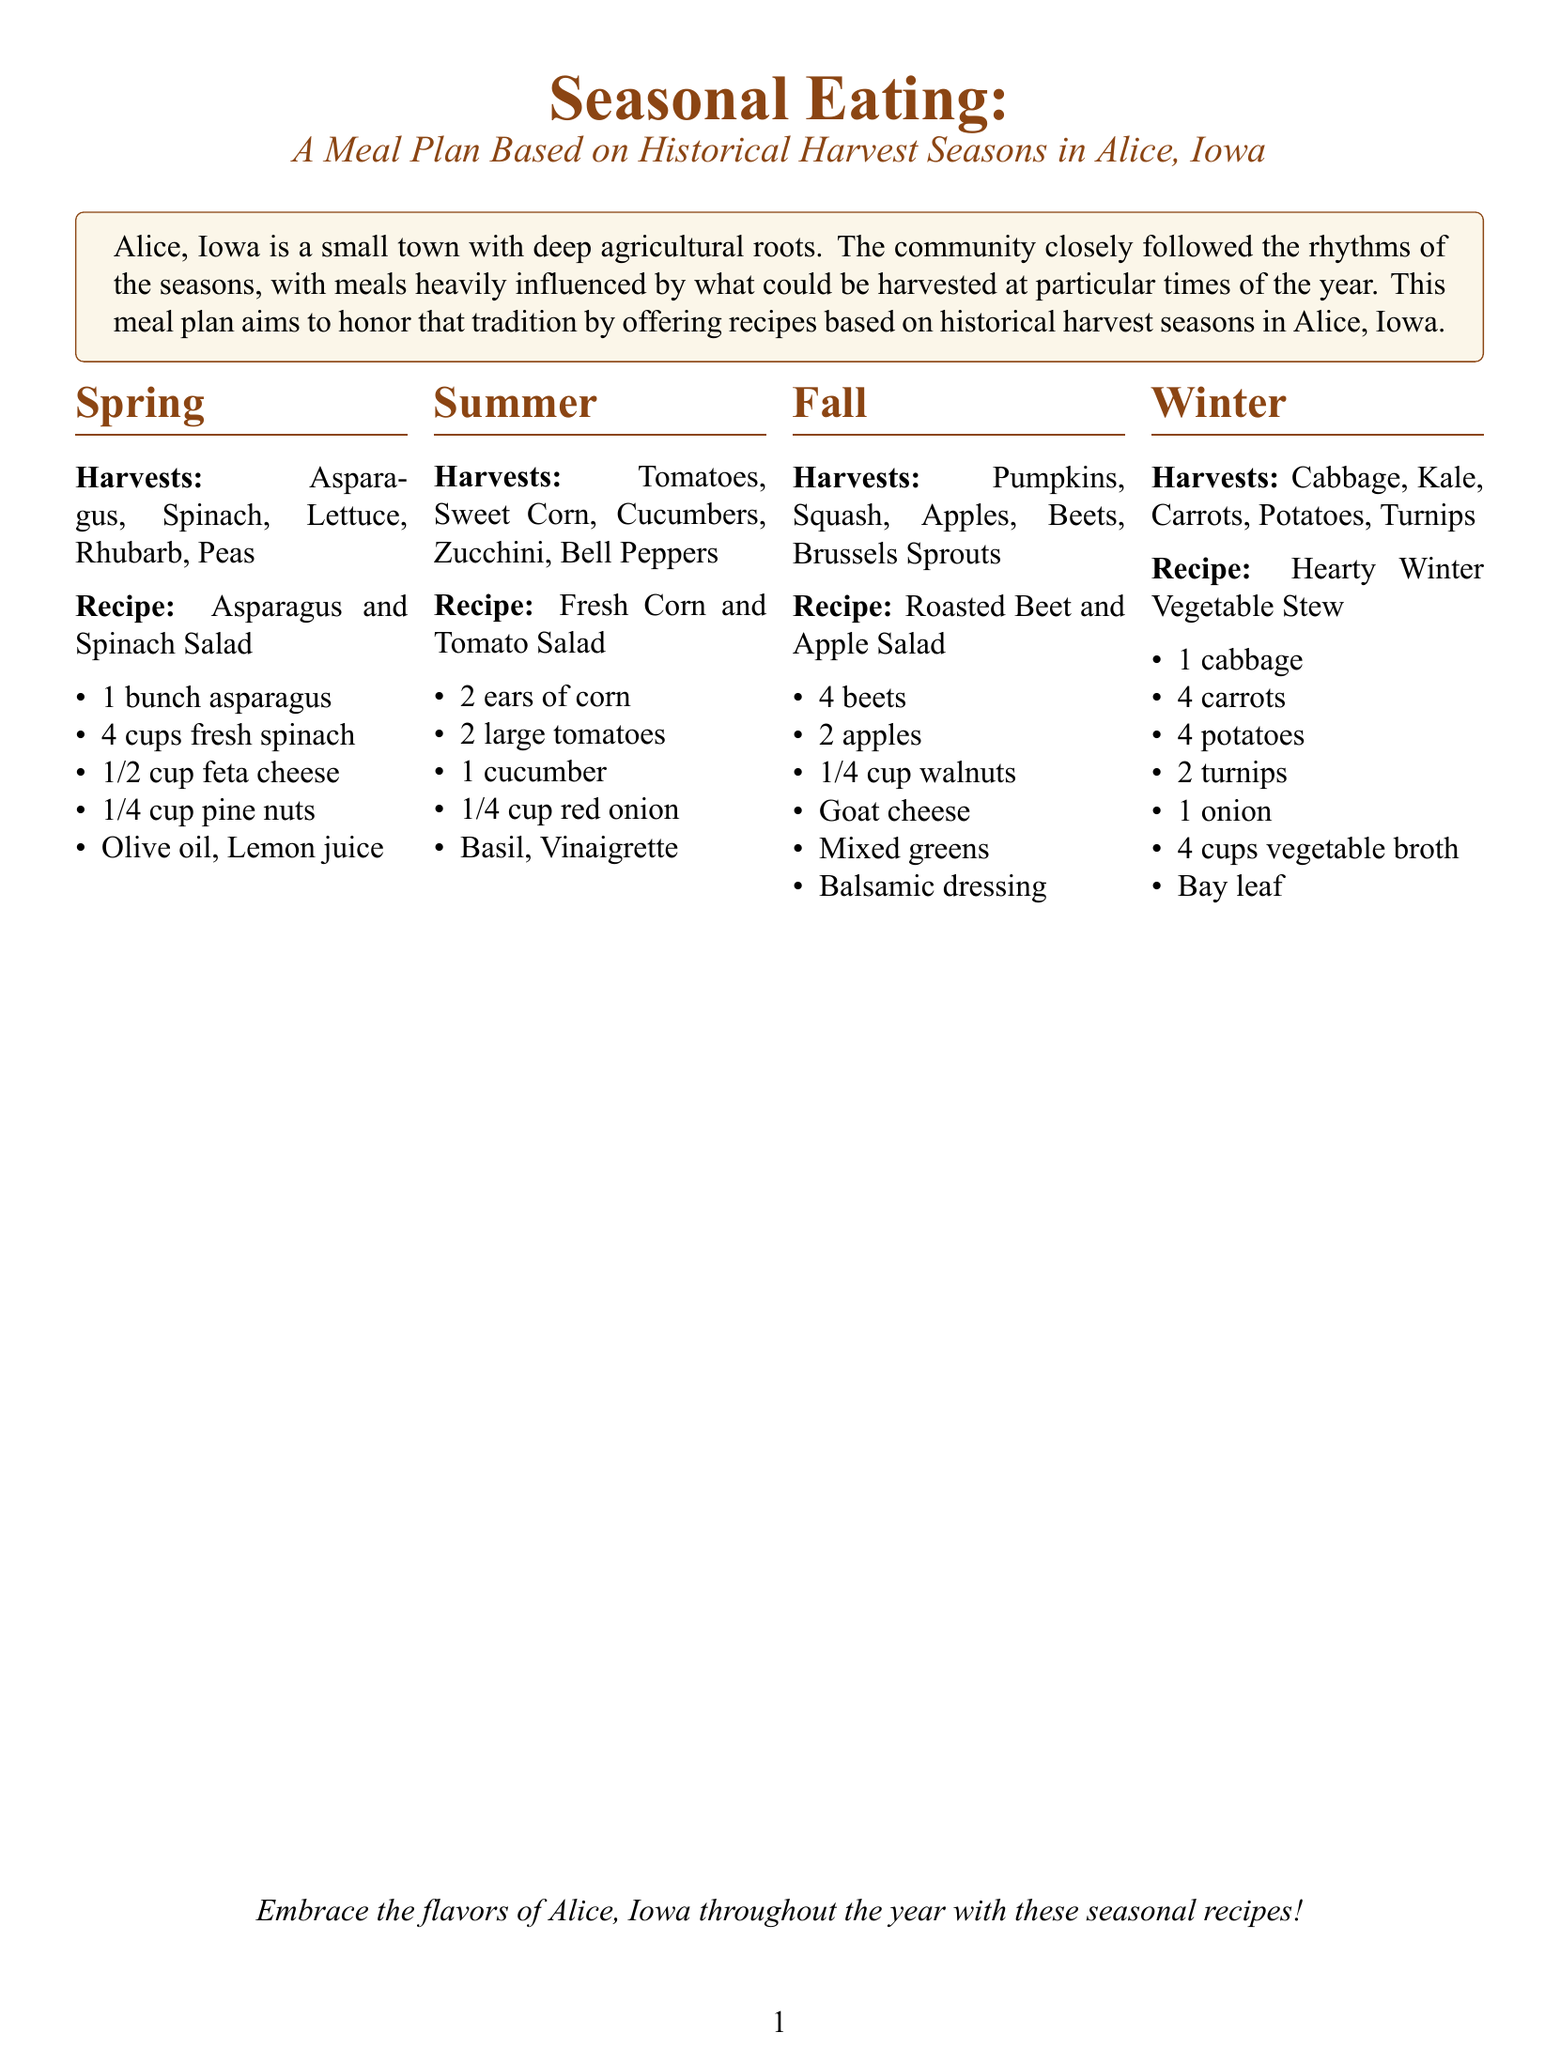What are the spring harvests listed? The spring harvests include specific vegetables and plants that can be grown and harvested in that season. The document lists Asparagus, Spinach, Lettuce, Rhubarb, and Peas.
Answer: Asparagus, Spinach, Lettuce, Rhubarb, Peas What is the summer recipe featured? The document mentions the seasonal recipe suitable for summer based on the ingredients harvested at that time. The recipe is Fresh Corn and Tomato Salad.
Answer: Fresh Corn and Tomato Salad How many main ingredients are in the Hearty Winter Vegetable Stew? The winter recipe includes a specific number of ingredients needed to make the stew, which can be counted. There are 7 main ingredients listed.
Answer: 7 What nut is used in the Roasted Beet and Apple Salad? This question pertains to the specific ingredient included in the fall recipe, which features a type of nut. The document specifies walnuts.
Answer: Walnuts Which season features Tomatoes as a harvest? The document provides details on which season certain vegetables are harvested, and specifically mentions that Tomatoes are harvested in summer.
Answer: Summer What vegetable is used in spring salads? A spring vegetable is highlighted as part of the seasonal eating plan, applicable to recipes mentioned in that section. The document lists Spinach.
Answer: Spinach What is the autumn fruit mentioned in the document? This question addresses the fall harvests detailed in the document, focusing on fruits harvested in that season. The document mentions Apples.
Answer: Apples What color is used for the section titles? The document describes the design choices made for the visual aspects of the sections, including the color for section titles. The sections are colored rustic brown.
Answer: Rustic brown What type of cheese is included in the Asparagus and Spinach Salad recipe? The question asks for a specific ingredient that contributes flavor in one of the salads described in the spring recipe. The document states feta cheese.
Answer: Feta cheese 